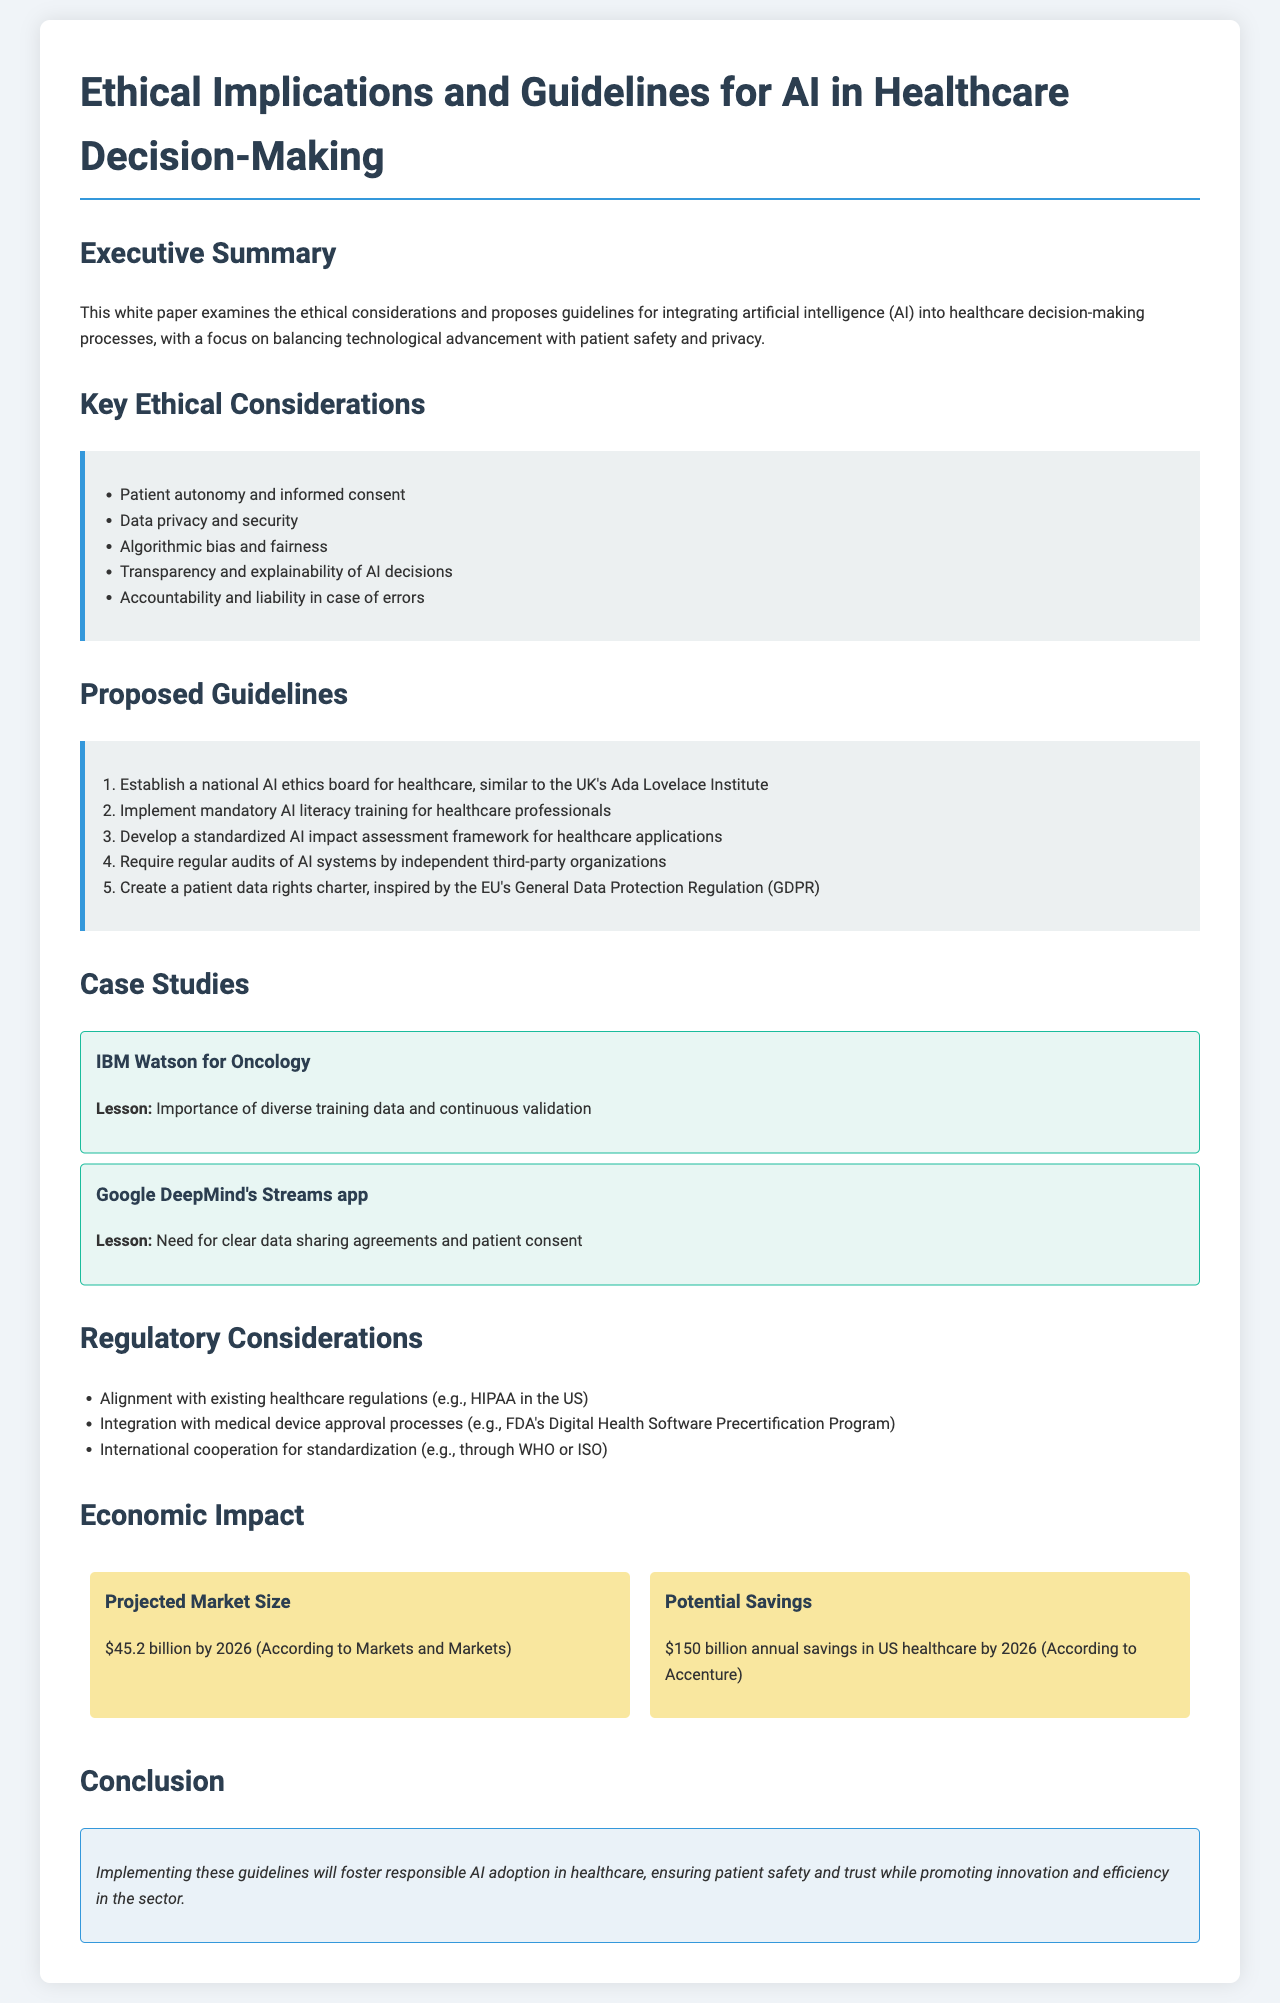What is the title of the white paper? The title clearly states the subject of the document concerning ethics and guidelines for AI in healthcare.
Answer: AI in Healthcare: Ethical Implications and Guidelines What is the projected market size for AI in healthcare by 2026? The document provides a specific figure for the projected market size, indicating the potential growth of AI applications in this sector.
Answer: $45.2 billion What lesson was learned from IBM Watson for Oncology? The case study section highlights key lessons learned from specific AI applications in healthcare.
Answer: Importance of diverse training data and continuous validation What is one of the key ethical considerations mentioned? The document lists several ethical considerations that are significant when deploying AI in healthcare.
Answer: Patient autonomy and informed consent Which organization is suggested to establish a national AI ethics board for healthcare? The proposed guidelines state a specific model for a national AI ethics board in healthcare that aligns with existing institutions.
Answer: Ada Lovelace Institute 